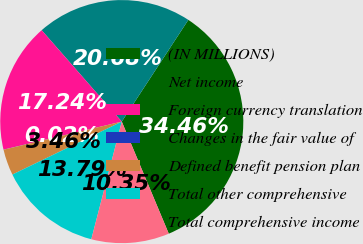<chart> <loc_0><loc_0><loc_500><loc_500><pie_chart><fcel>(IN MILLIONS)<fcel>Net income<fcel>Foreign currency translation<fcel>Changes in the fair value of<fcel>Defined benefit pension plan<fcel>Total other comprehensive<fcel>Total comprehensive income<nl><fcel>34.46%<fcel>20.68%<fcel>17.24%<fcel>0.02%<fcel>3.46%<fcel>13.79%<fcel>10.35%<nl></chart> 